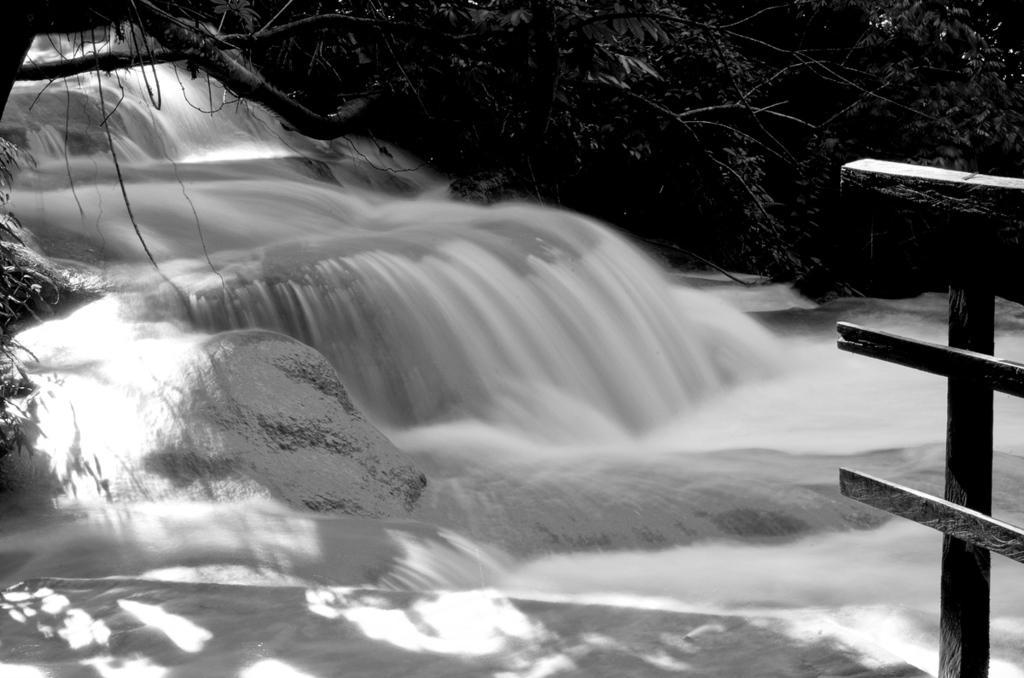Could you give a brief overview of what you see in this image? In the picture I can see water flowing and there is a fence in the right corner and there are trees in the background. 